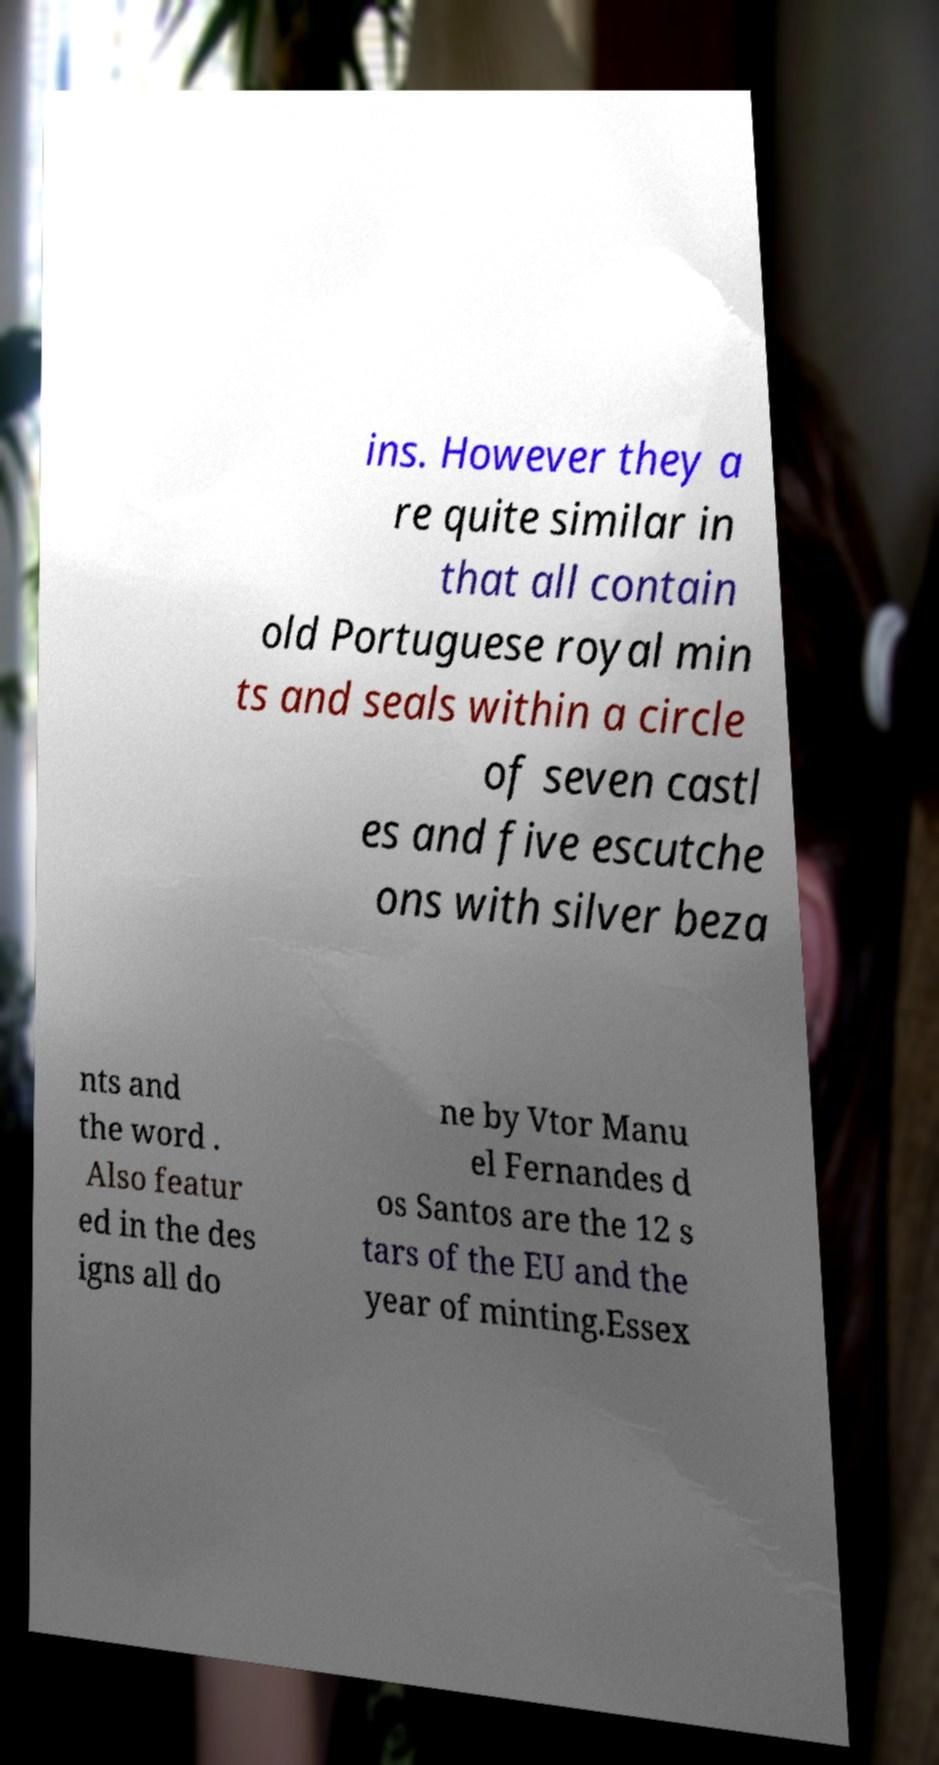There's text embedded in this image that I need extracted. Can you transcribe it verbatim? ins. However they a re quite similar in that all contain old Portuguese royal min ts and seals within a circle of seven castl es and five escutche ons with silver beza nts and the word . Also featur ed in the des igns all do ne by Vtor Manu el Fernandes d os Santos are the 12 s tars of the EU and the year of minting.Essex 